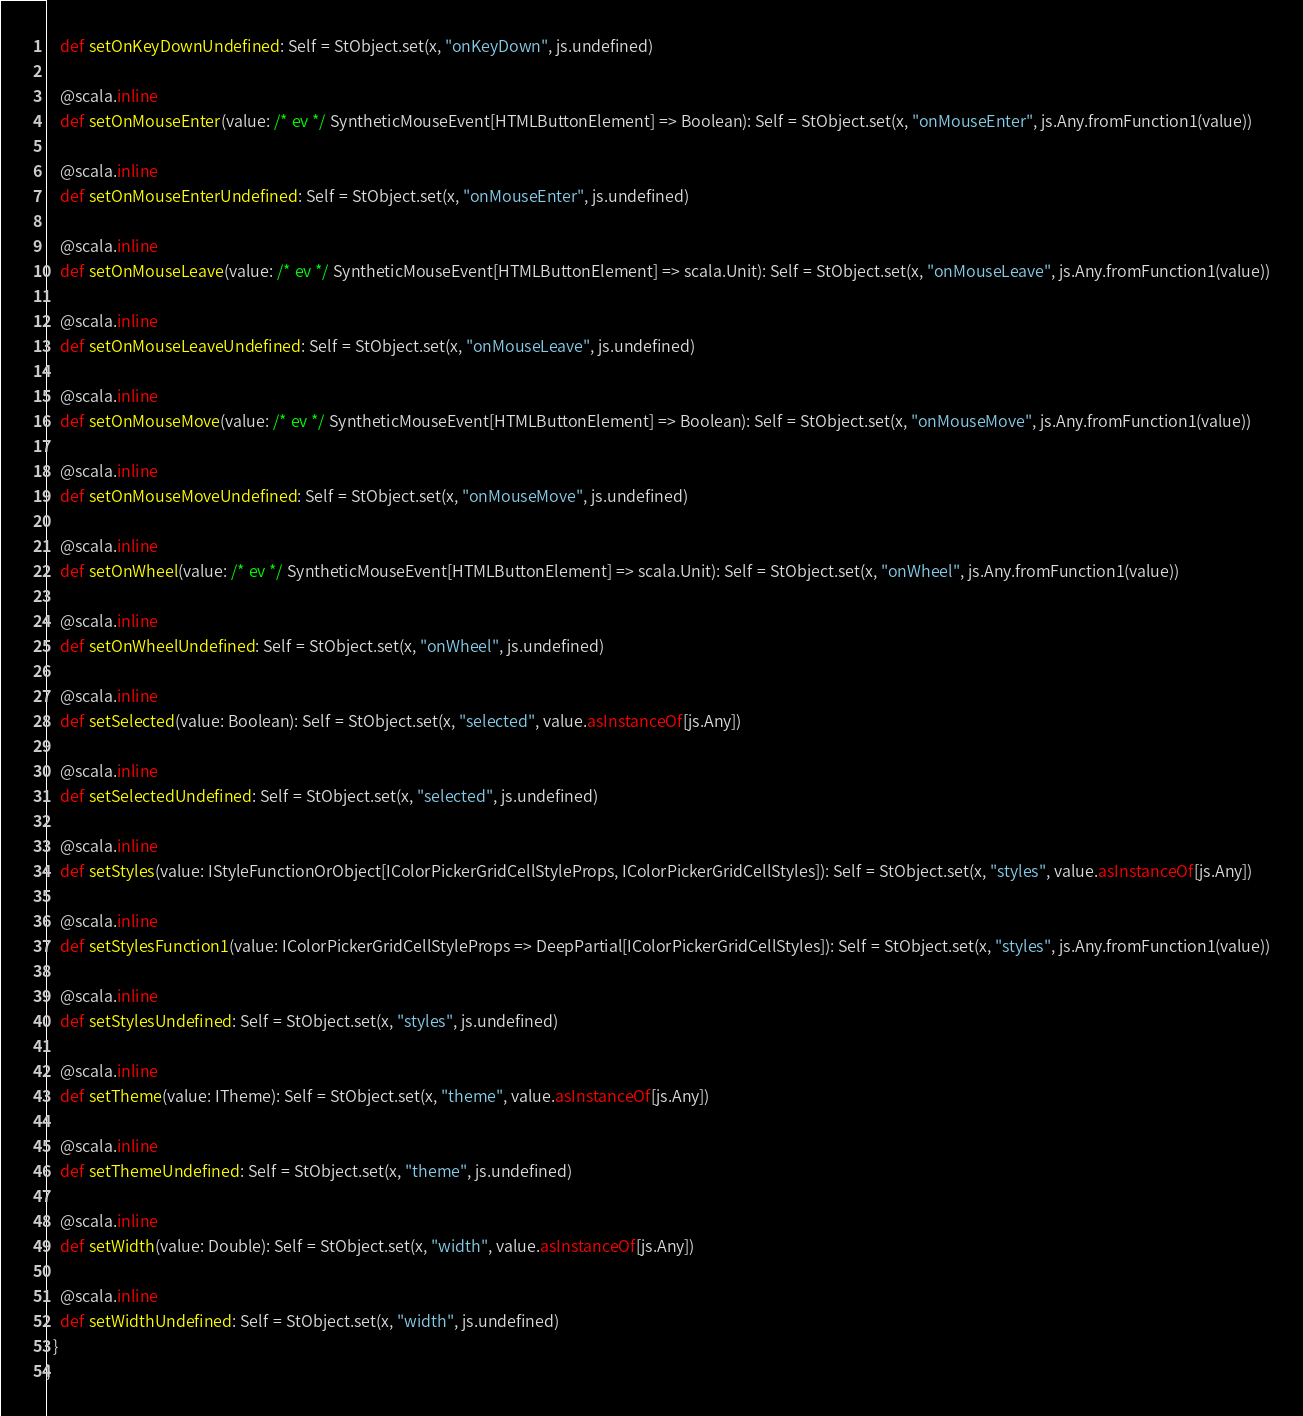Convert code to text. <code><loc_0><loc_0><loc_500><loc_500><_Scala_>    def setOnKeyDownUndefined: Self = StObject.set(x, "onKeyDown", js.undefined)
    
    @scala.inline
    def setOnMouseEnter(value: /* ev */ SyntheticMouseEvent[HTMLButtonElement] => Boolean): Self = StObject.set(x, "onMouseEnter", js.Any.fromFunction1(value))
    
    @scala.inline
    def setOnMouseEnterUndefined: Self = StObject.set(x, "onMouseEnter", js.undefined)
    
    @scala.inline
    def setOnMouseLeave(value: /* ev */ SyntheticMouseEvent[HTMLButtonElement] => scala.Unit): Self = StObject.set(x, "onMouseLeave", js.Any.fromFunction1(value))
    
    @scala.inline
    def setOnMouseLeaveUndefined: Self = StObject.set(x, "onMouseLeave", js.undefined)
    
    @scala.inline
    def setOnMouseMove(value: /* ev */ SyntheticMouseEvent[HTMLButtonElement] => Boolean): Self = StObject.set(x, "onMouseMove", js.Any.fromFunction1(value))
    
    @scala.inline
    def setOnMouseMoveUndefined: Self = StObject.set(x, "onMouseMove", js.undefined)
    
    @scala.inline
    def setOnWheel(value: /* ev */ SyntheticMouseEvent[HTMLButtonElement] => scala.Unit): Self = StObject.set(x, "onWheel", js.Any.fromFunction1(value))
    
    @scala.inline
    def setOnWheelUndefined: Self = StObject.set(x, "onWheel", js.undefined)
    
    @scala.inline
    def setSelected(value: Boolean): Self = StObject.set(x, "selected", value.asInstanceOf[js.Any])
    
    @scala.inline
    def setSelectedUndefined: Self = StObject.set(x, "selected", js.undefined)
    
    @scala.inline
    def setStyles(value: IStyleFunctionOrObject[IColorPickerGridCellStyleProps, IColorPickerGridCellStyles]): Self = StObject.set(x, "styles", value.asInstanceOf[js.Any])
    
    @scala.inline
    def setStylesFunction1(value: IColorPickerGridCellStyleProps => DeepPartial[IColorPickerGridCellStyles]): Self = StObject.set(x, "styles", js.Any.fromFunction1(value))
    
    @scala.inline
    def setStylesUndefined: Self = StObject.set(x, "styles", js.undefined)
    
    @scala.inline
    def setTheme(value: ITheme): Self = StObject.set(x, "theme", value.asInstanceOf[js.Any])
    
    @scala.inline
    def setThemeUndefined: Self = StObject.set(x, "theme", js.undefined)
    
    @scala.inline
    def setWidth(value: Double): Self = StObject.set(x, "width", value.asInstanceOf[js.Any])
    
    @scala.inline
    def setWidthUndefined: Self = StObject.set(x, "width", js.undefined)
  }
}
</code> 